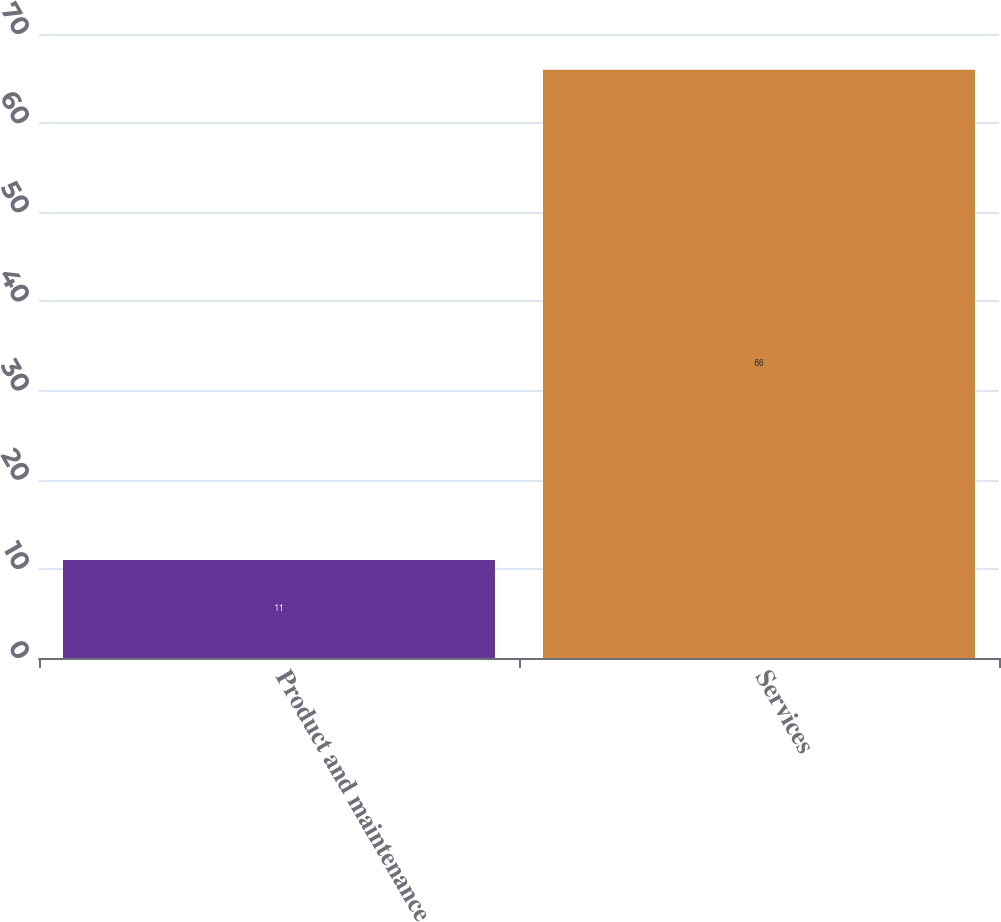Convert chart. <chart><loc_0><loc_0><loc_500><loc_500><bar_chart><fcel>Product and maintenance<fcel>Services<nl><fcel>11<fcel>66<nl></chart> 